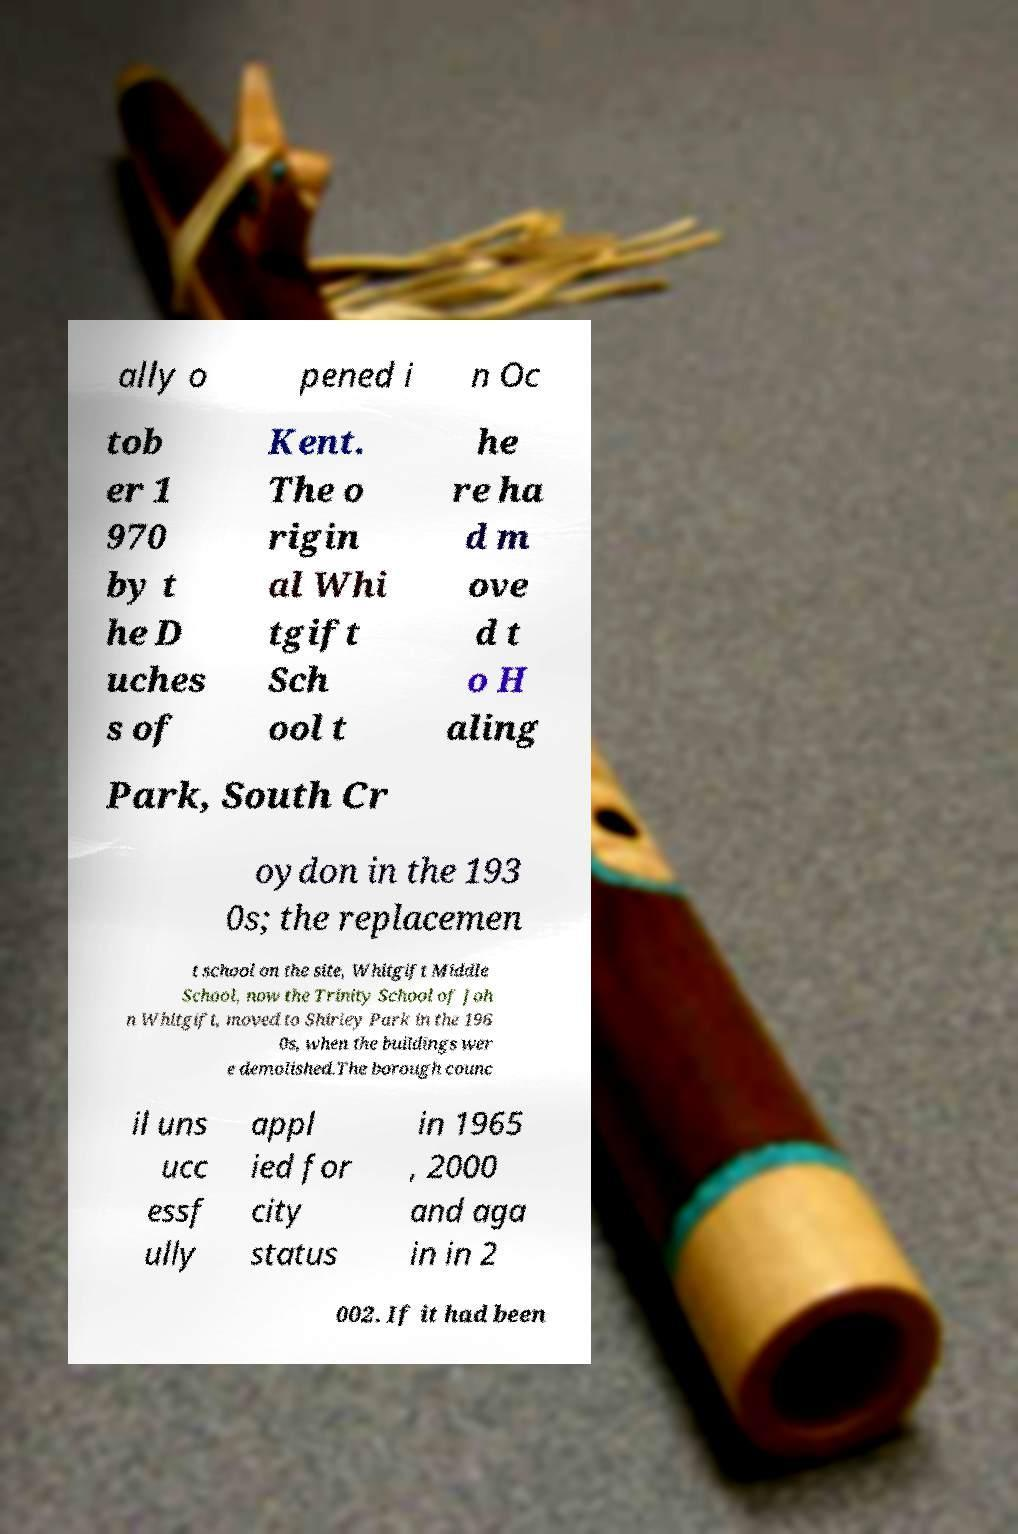For documentation purposes, I need the text within this image transcribed. Could you provide that? ally o pened i n Oc tob er 1 970 by t he D uches s of Kent. The o rigin al Whi tgift Sch ool t he re ha d m ove d t o H aling Park, South Cr oydon in the 193 0s; the replacemen t school on the site, Whitgift Middle School, now the Trinity School of Joh n Whitgift, moved to Shirley Park in the 196 0s, when the buildings wer e demolished.The borough counc il uns ucc essf ully appl ied for city status in 1965 , 2000 and aga in in 2 002. If it had been 